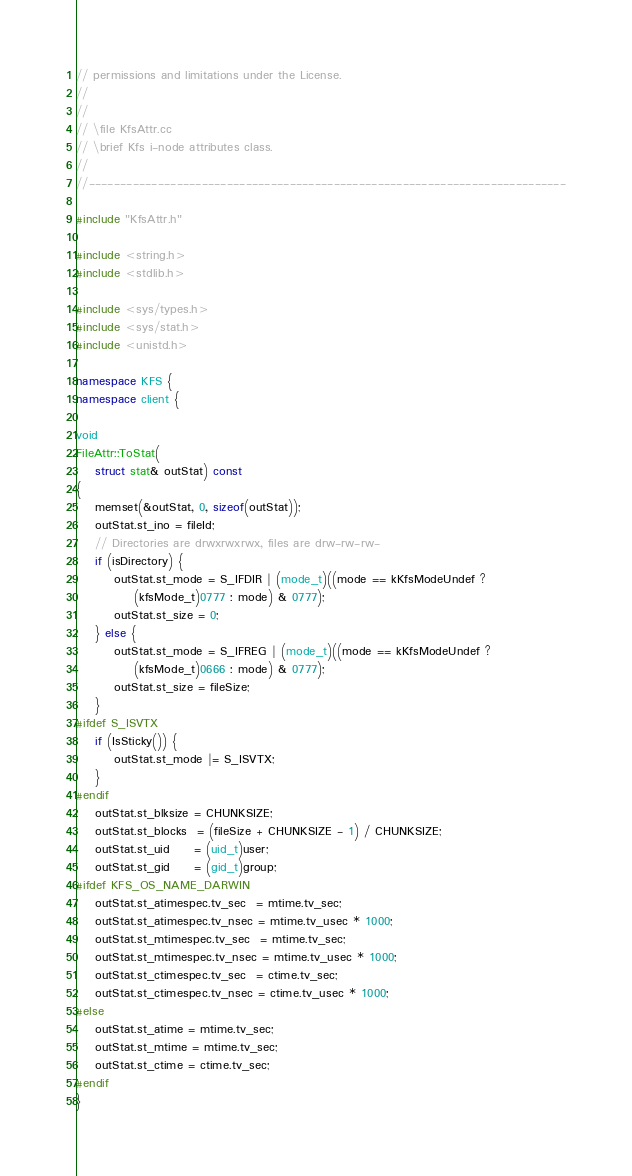Convert code to text. <code><loc_0><loc_0><loc_500><loc_500><_C++_>// permissions and limitations under the License.
//
//
// \file KfsAttr.cc
// \brief Kfs i-node attributes class.
//
//----------------------------------------------------------------------------

#include "KfsAttr.h"

#include <string.h>
#include <stdlib.h>

#include <sys/types.h>
#include <sys/stat.h>
#include <unistd.h>

namespace KFS {
namespace client {

void
FileAttr::ToStat(
    struct stat& outStat) const
{
    memset(&outStat, 0, sizeof(outStat));
    outStat.st_ino = fileId;
    // Directories are drwxrwxrwx, files are drw-rw-rw-
    if (isDirectory) {
        outStat.st_mode = S_IFDIR | (mode_t)((mode == kKfsModeUndef ?
            (kfsMode_t)0777 : mode) & 0777);
        outStat.st_size = 0;
    } else {
        outStat.st_mode = S_IFREG | (mode_t)((mode == kKfsModeUndef ?
            (kfsMode_t)0666 : mode) & 0777);
        outStat.st_size = fileSize;
    }
#ifdef S_ISVTX
    if (IsSticky()) {
        outStat.st_mode |= S_ISVTX;
    }
#endif
    outStat.st_blksize = CHUNKSIZE;
    outStat.st_blocks  = (fileSize + CHUNKSIZE - 1) / CHUNKSIZE;
    outStat.st_uid     = (uid_t)user;
    outStat.st_gid     = (gid_t)group;
#ifdef KFS_OS_NAME_DARWIN
    outStat.st_atimespec.tv_sec  = mtime.tv_sec;
    outStat.st_atimespec.tv_nsec = mtime.tv_usec * 1000;
    outStat.st_mtimespec.tv_sec  = mtime.tv_sec;
    outStat.st_mtimespec.tv_nsec = mtime.tv_usec * 1000;
    outStat.st_ctimespec.tv_sec  = ctime.tv_sec;
    outStat.st_ctimespec.tv_nsec = ctime.tv_usec * 1000;
#else
    outStat.st_atime = mtime.tv_sec;
    outStat.st_mtime = mtime.tv_sec;
    outStat.st_ctime = ctime.tv_sec;
#endif
}
</code> 